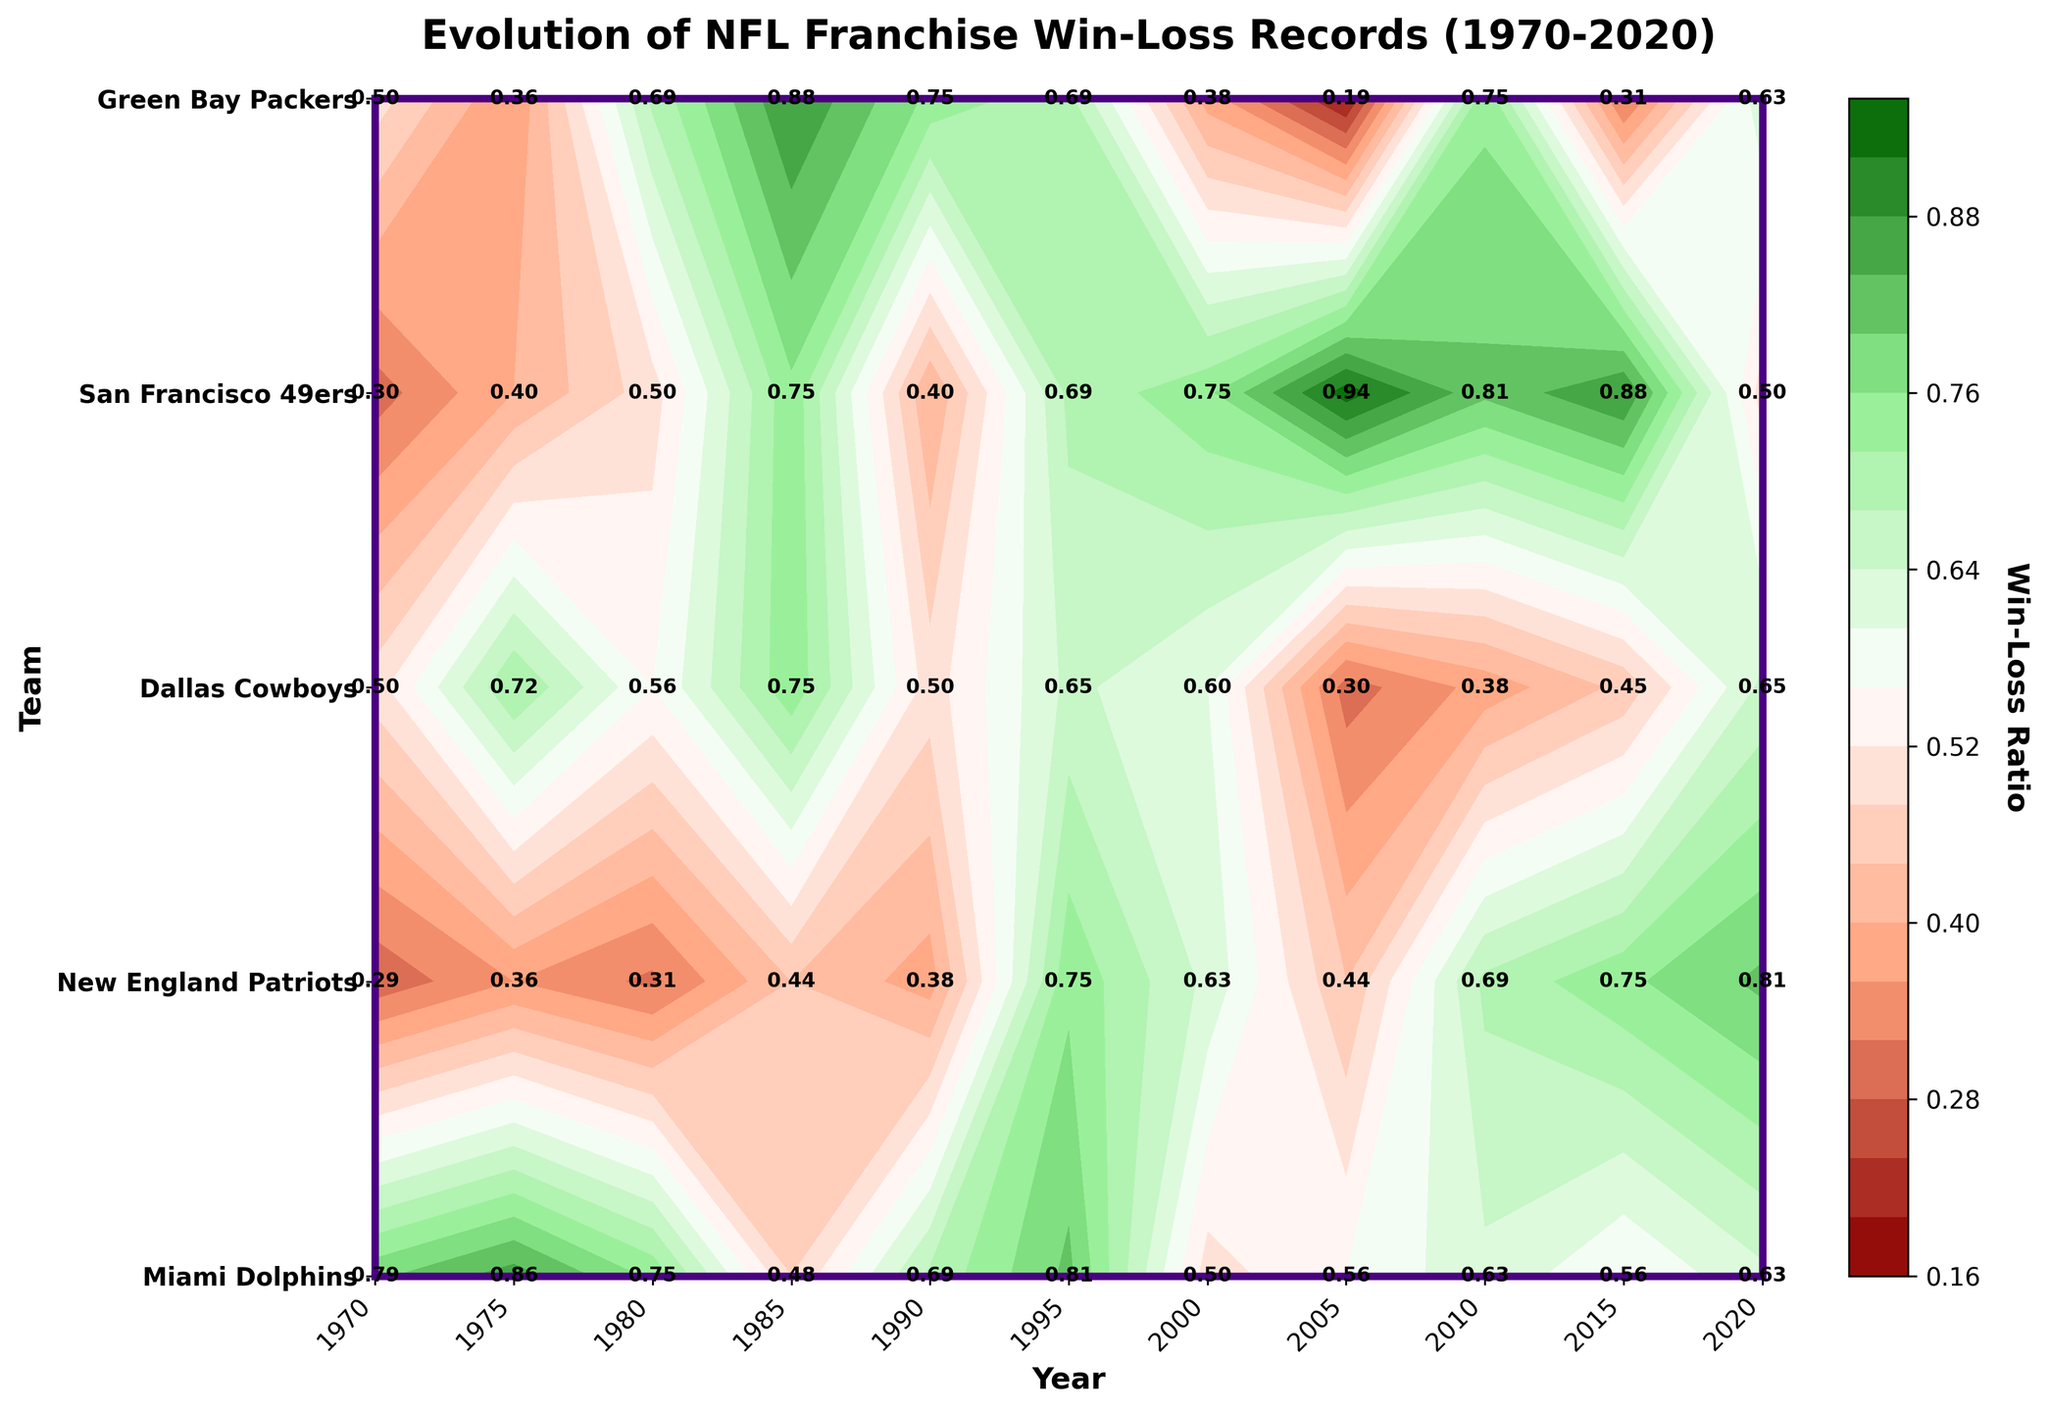What is the title of the plot? The title is displayed at the top of the plot and reads "Evolution of NFL Franchise Win-Loss Records (1970-2020)."
Answer: Evolution of NFL Franchise Win-Loss Records (1970-2020) Which team had the highest win-loss ratio in 2005? By looking at the win-loss ratios for each team in the column corresponding to 2005, the New England Patriots had the highest ratio of 0.94.
Answer: New England Patriots What colors are used in the colormap to represent the win-loss ratio? The custom colormap uses a gradient from dark red to light salmon, white, light green, and dark green.
Answer: Dark red, Light salmon, White, Light green, Dark green How did the win-loss ratio for the San Francisco 49ers change from 2000 to 2010? In 2000, the win-loss ratio for the 49ers was 0.38. It significantly dropped to 0.19 in 2005 and then increased to 0.75 by 2010.
Answer: Decreased from 0.38 to 0.19 and then increased to 0.75 Which year did the Dallas Cowboys achieve their highest win-loss ratio? Referring to the contour plot, the largest value for the Dallas Cowboys is in 1975 with a win-loss ratio of 0.86.
Answer: 1975 Compare the win-loss ratios for the Miami Dolphins and New England Patriots in the year 2000. Which team had a higher ratio? In the year 2000, the Miami Dolphins had a win-loss ratio of 0.6 while the New England Patriots had a win-loss ratio of 0.75. Therefore, the Patriots had a higher win-loss ratio.
Answer: New England Patriots What trends can you observe for the Green Bay Packers' win-loss ratios from 1970 to 2020? Starting with a low ratio of 0.29 in 1970, the Packers' performance wavered with an evident upward trend hitting a high of 0.81 in 2020, especially post-1995.
Answer: Increasing trend with fluctuation, peaking in 2020 Which team had the most stable win-loss ratio, and what evidence supports your answer? The New England Patriots had the most stable win-loss ratio, maintaining relatively high performance from 1995 onwards, consistently above 0.5 with notable peaks like 0.94 in 2005.
Answer: New England Patriots 